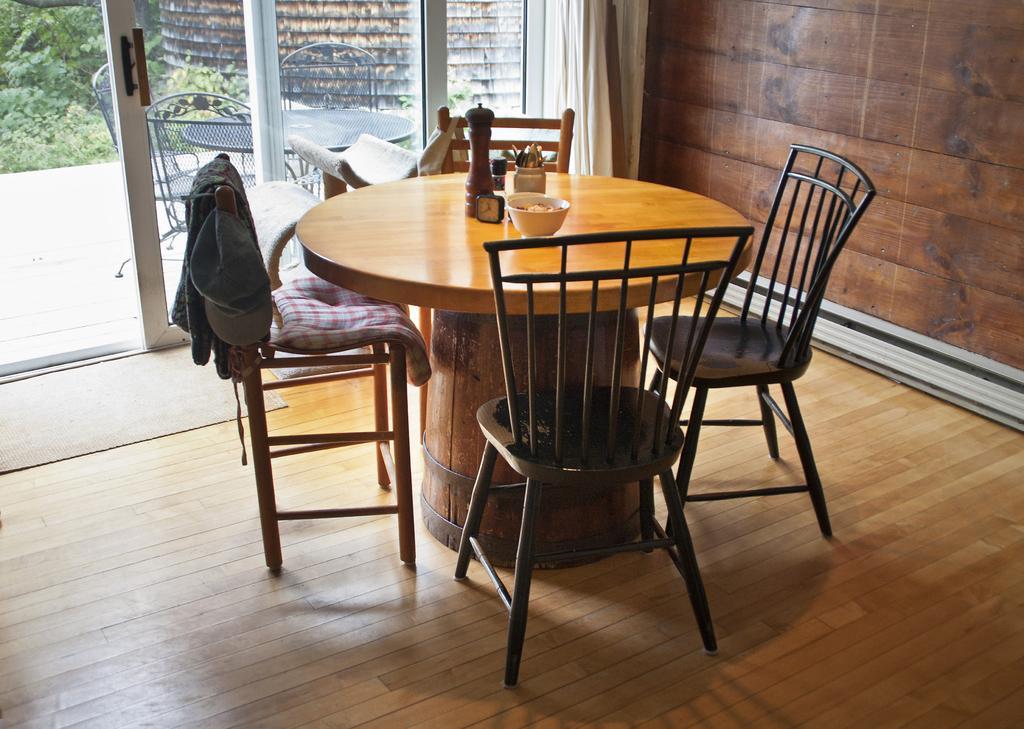How would you summarize this image in a sentence or two? Here we can see a table and chairs arrangement. Here we can see a glass door. 